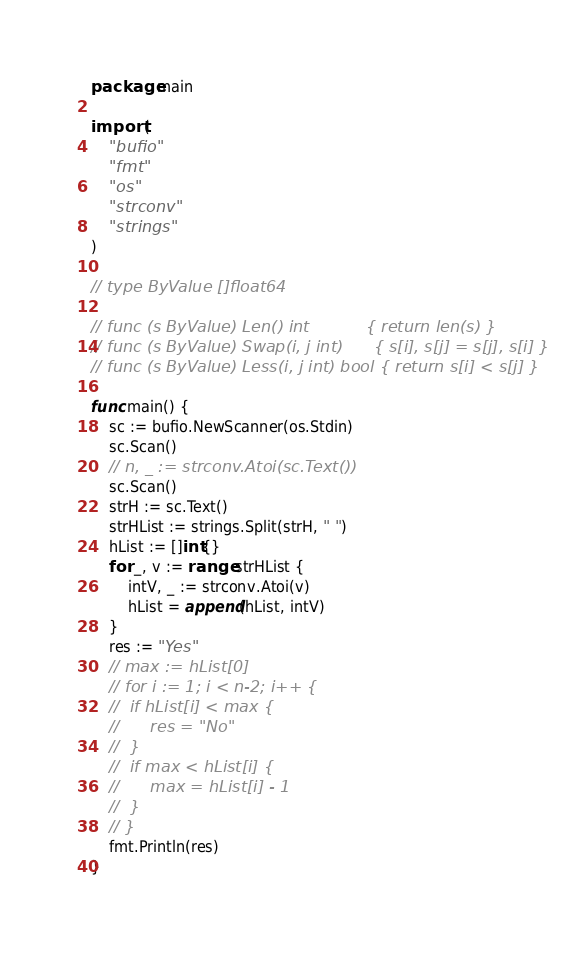Convert code to text. <code><loc_0><loc_0><loc_500><loc_500><_Go_>package main

import (
	"bufio"
	"fmt"
	"os"
	"strconv"
	"strings"
)

// type ByValue []float64

// func (s ByValue) Len() int           { return len(s) }
// func (s ByValue) Swap(i, j int)      { s[i], s[j] = s[j], s[i] }
// func (s ByValue) Less(i, j int) bool { return s[i] < s[j] }

func main() {
	sc := bufio.NewScanner(os.Stdin)
	sc.Scan()
	// n, _ := strconv.Atoi(sc.Text())
	sc.Scan()
	strH := sc.Text()
	strHList := strings.Split(strH, " ")
	hList := []int{}
	for _, v := range strHList {
		intV, _ := strconv.Atoi(v)
		hList = append(hList, intV)
	}
	res := "Yes"
	// max := hList[0]
	// for i := 1; i < n-2; i++ {
	// 	if hList[i] < max {
	// 		res = "No"
	// 	}
	// 	if max < hList[i] {
	// 		max = hList[i] - 1
	// 	}
	// }
	fmt.Println(res)
}
</code> 